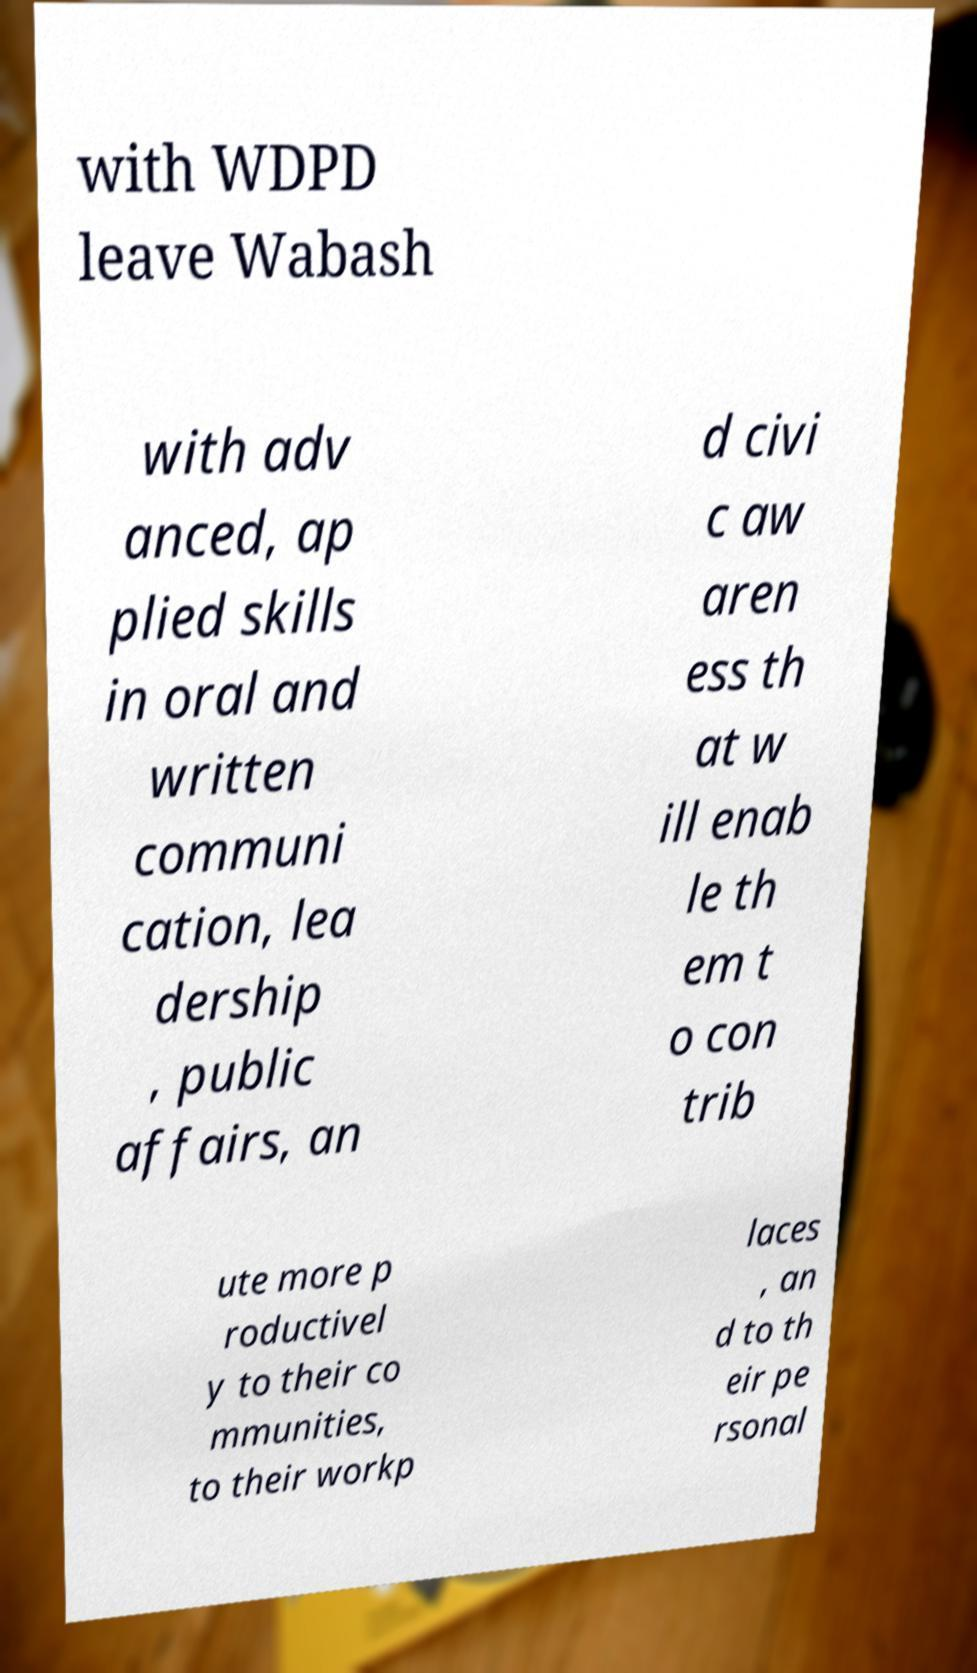What messages or text are displayed in this image? I need them in a readable, typed format. with WDPD leave Wabash with adv anced, ap plied skills in oral and written communi cation, lea dership , public affairs, an d civi c aw aren ess th at w ill enab le th em t o con trib ute more p roductivel y to their co mmunities, to their workp laces , an d to th eir pe rsonal 